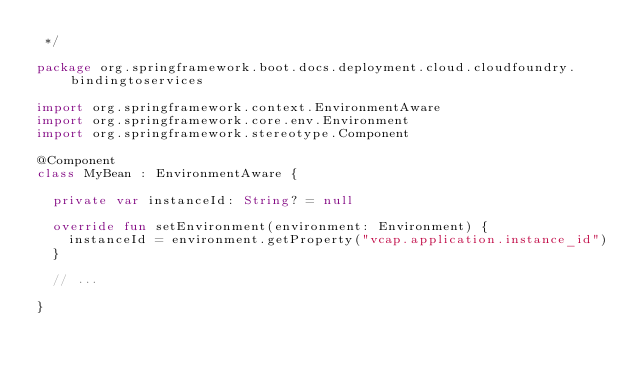Convert code to text. <code><loc_0><loc_0><loc_500><loc_500><_Kotlin_> */

package org.springframework.boot.docs.deployment.cloud.cloudfoundry.bindingtoservices

import org.springframework.context.EnvironmentAware
import org.springframework.core.env.Environment
import org.springframework.stereotype.Component

@Component
class MyBean : EnvironmentAware {

	private var instanceId: String? = null

	override fun setEnvironment(environment: Environment) {
		instanceId = environment.getProperty("vcap.application.instance_id")
	}

	// ...

}</code> 